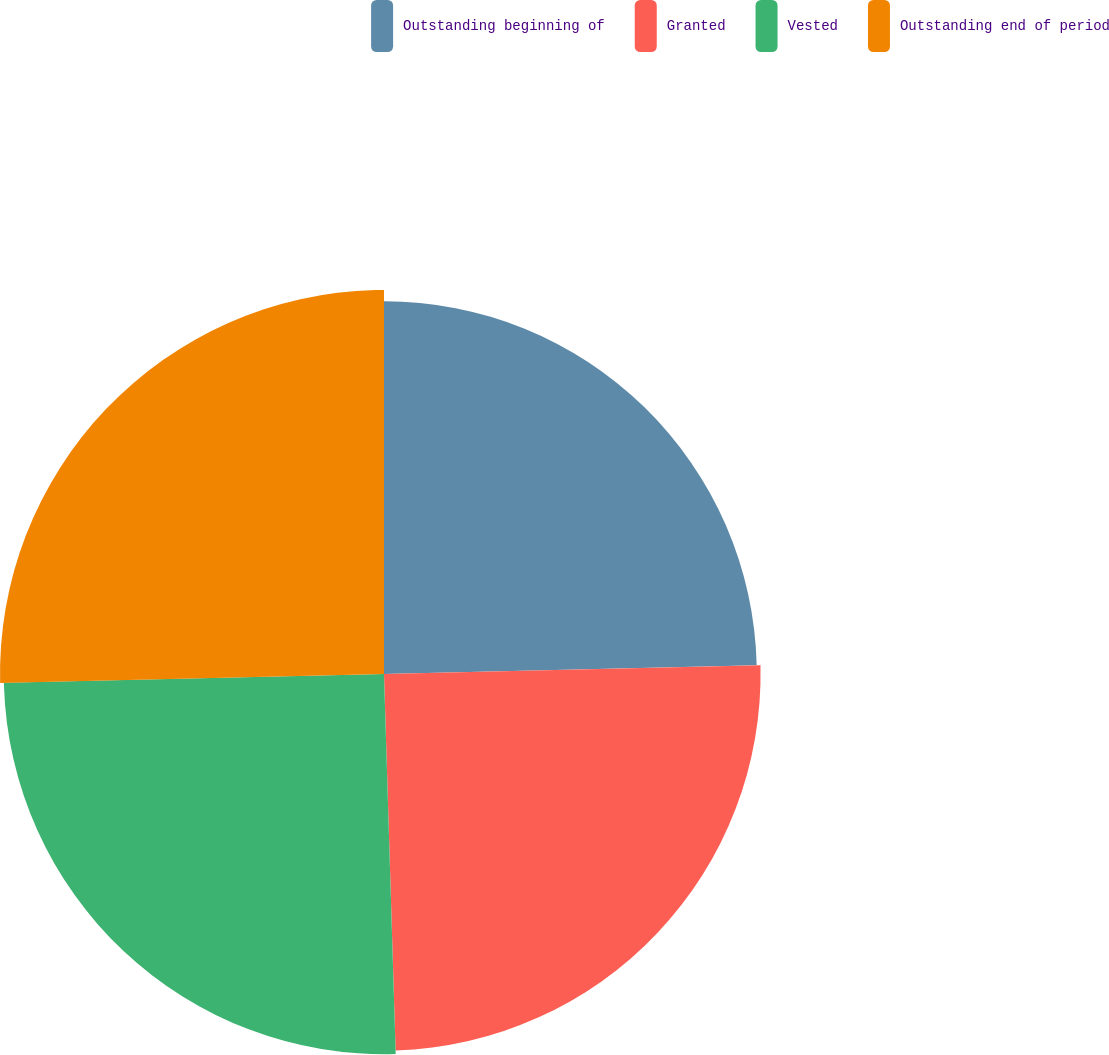Convert chart to OTSL. <chart><loc_0><loc_0><loc_500><loc_500><pie_chart><fcel>Outstanding beginning of<fcel>Granted<fcel>Vested<fcel>Outstanding end of period<nl><fcel>24.63%<fcel>24.88%<fcel>25.12%<fcel>25.37%<nl></chart> 